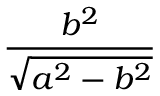<formula> <loc_0><loc_0><loc_500><loc_500>\frac { b ^ { 2 } } { \sqrt { a ^ { 2 } - b ^ { 2 } } }</formula> 